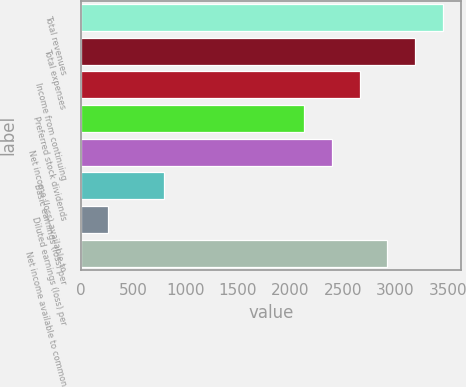Convert chart. <chart><loc_0><loc_0><loc_500><loc_500><bar_chart><fcel>Total revenues<fcel>Total expenses<fcel>Income from continuing<fcel>Preferred stock dividends<fcel>Net income (loss) available to<fcel>Basic earnings (loss) per<fcel>Diluted earnings (loss) per<fcel>Net income available to common<nl><fcel>3455.52<fcel>3189.76<fcel>2658.24<fcel>2126.72<fcel>2392.48<fcel>797.92<fcel>266.4<fcel>2924<nl></chart> 